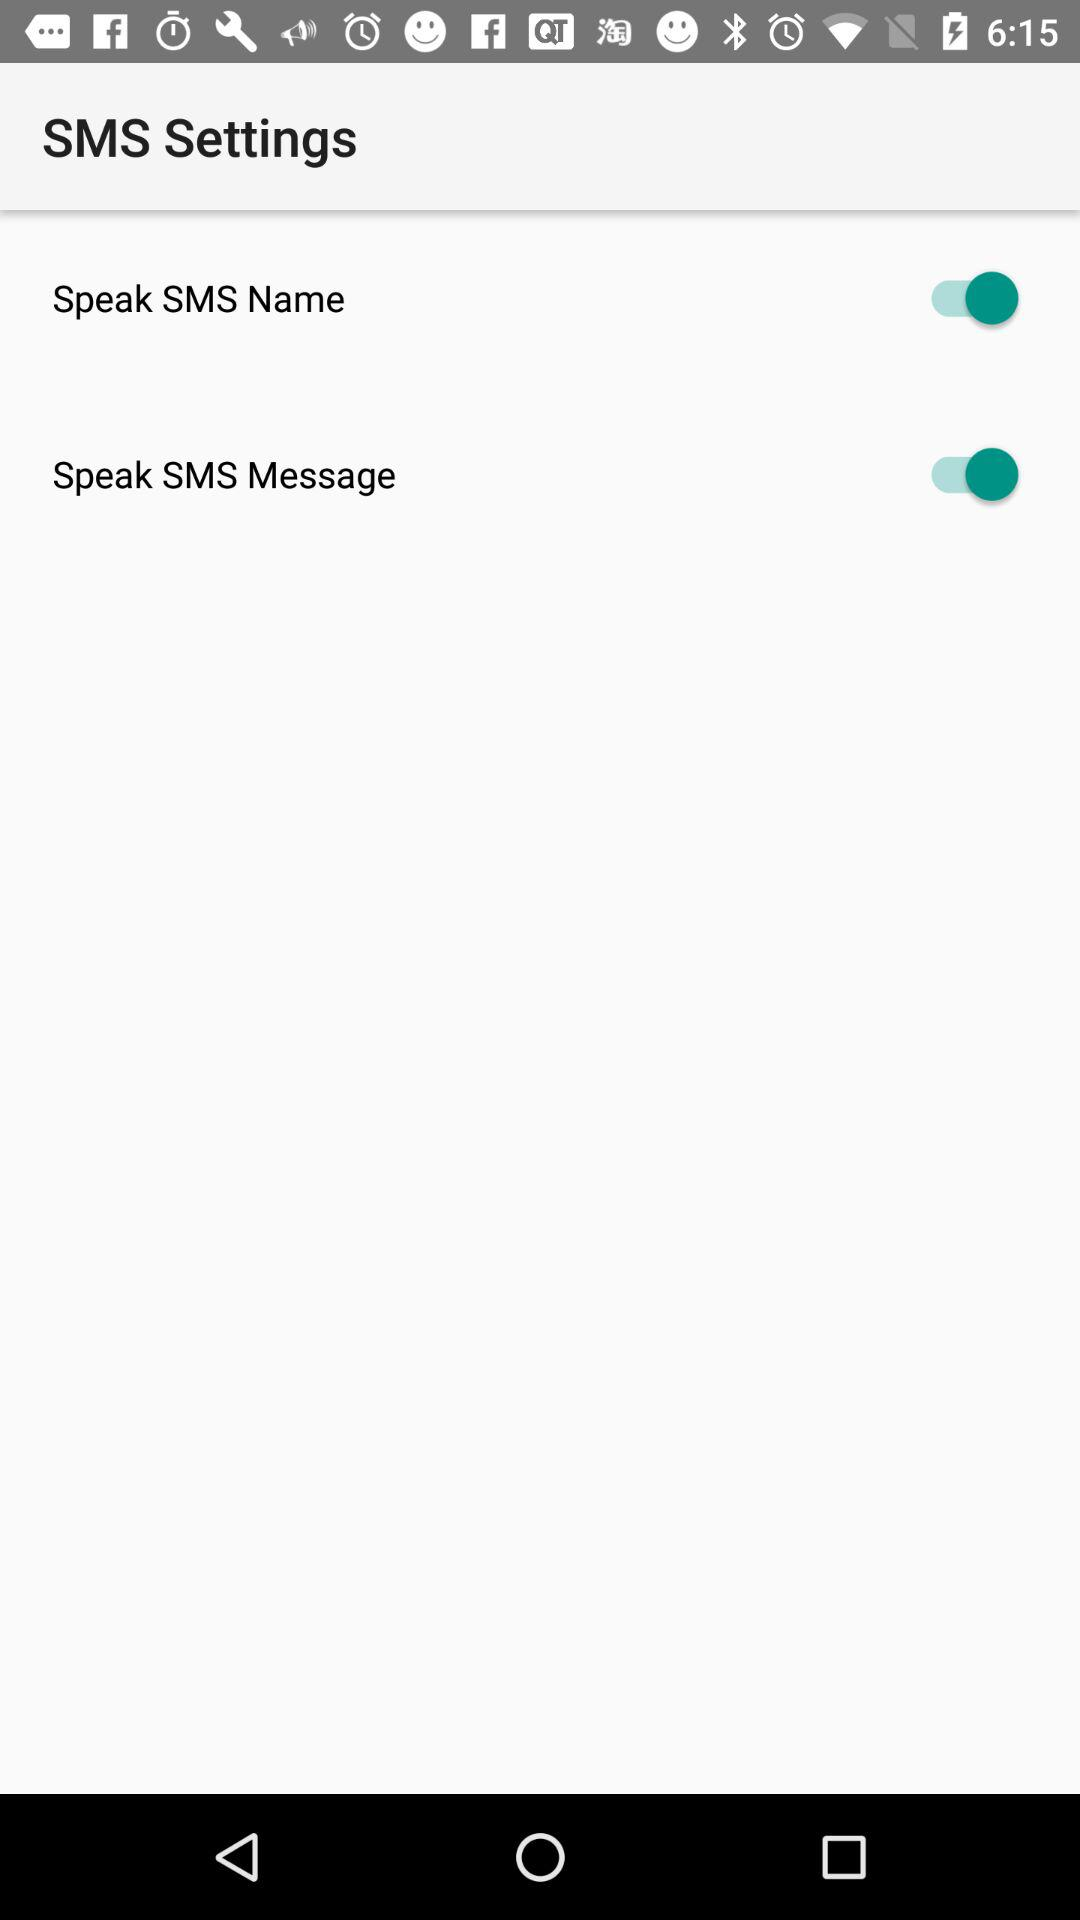How many switches are there in the SMS settings?
Answer the question using a single word or phrase. 2 